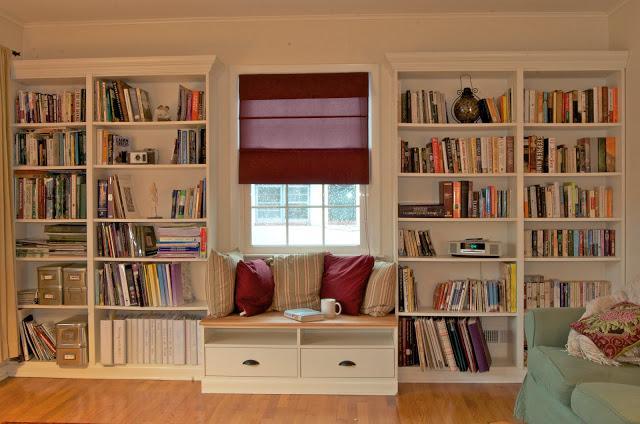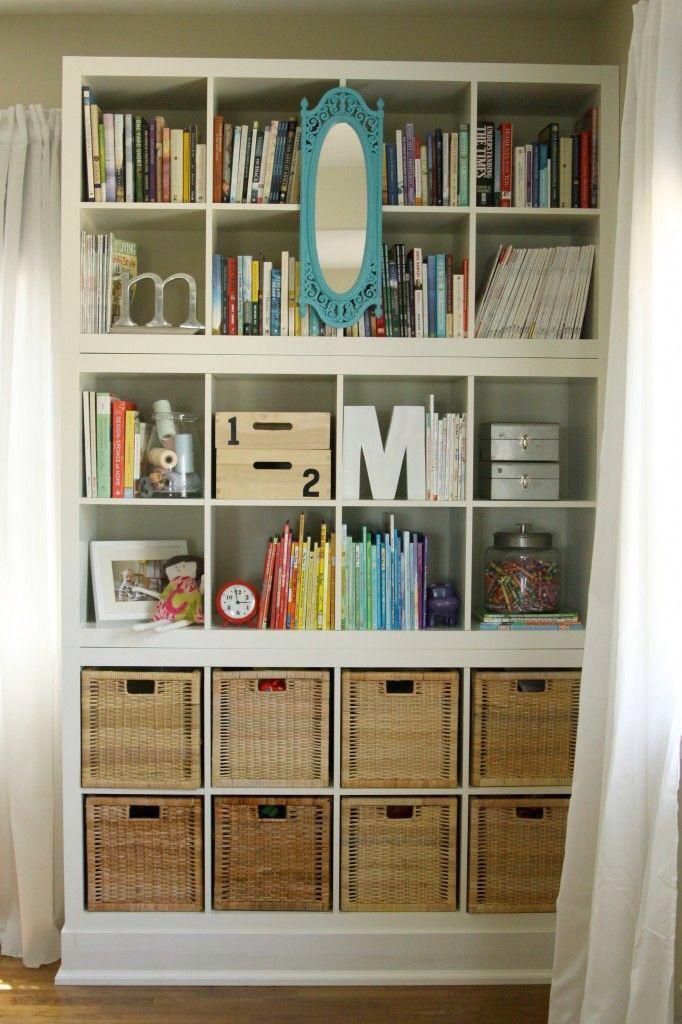The first image is the image on the left, the second image is the image on the right. Given the left and right images, does the statement "there is a white bookshelf with a mirror hanging on it" hold true? Answer yes or no. Yes. 